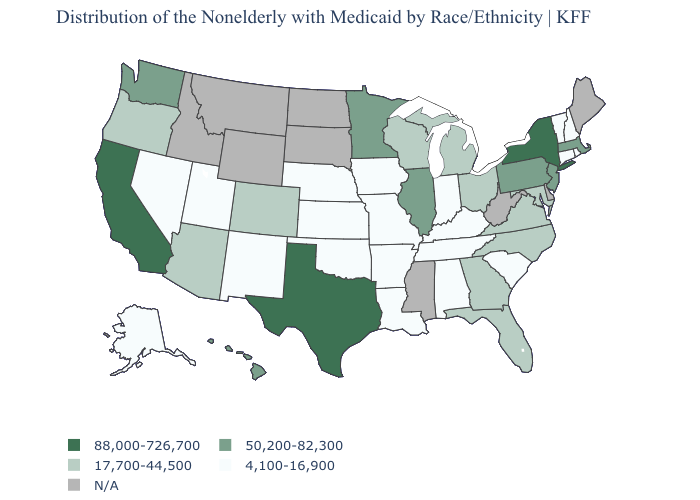Does the first symbol in the legend represent the smallest category?
Keep it brief. No. Among the states that border Wisconsin , does Minnesota have the highest value?
Concise answer only. Yes. Among the states that border Colorado , does Arizona have the highest value?
Give a very brief answer. Yes. Does Alaska have the lowest value in the USA?
Answer briefly. Yes. Which states have the lowest value in the West?
Give a very brief answer. Alaska, Nevada, New Mexico, Utah. What is the value of West Virginia?
Give a very brief answer. N/A. Name the states that have a value in the range 17,700-44,500?
Give a very brief answer. Arizona, Colorado, Florida, Georgia, Maryland, Michigan, North Carolina, Ohio, Oregon, Virginia, Wisconsin. Name the states that have a value in the range 50,200-82,300?
Write a very short answer. Hawaii, Illinois, Massachusetts, Minnesota, New Jersey, Pennsylvania, Washington. Name the states that have a value in the range 17,700-44,500?
Keep it brief. Arizona, Colorado, Florida, Georgia, Maryland, Michigan, North Carolina, Ohio, Oregon, Virginia, Wisconsin. What is the highest value in the USA?
Quick response, please. 88,000-726,700. What is the highest value in the USA?
Short answer required. 88,000-726,700. Does Vermont have the lowest value in the Northeast?
Write a very short answer. Yes. What is the value of Arkansas?
Answer briefly. 4,100-16,900. Does the map have missing data?
Write a very short answer. Yes. Name the states that have a value in the range 88,000-726,700?
Be succinct. California, New York, Texas. 